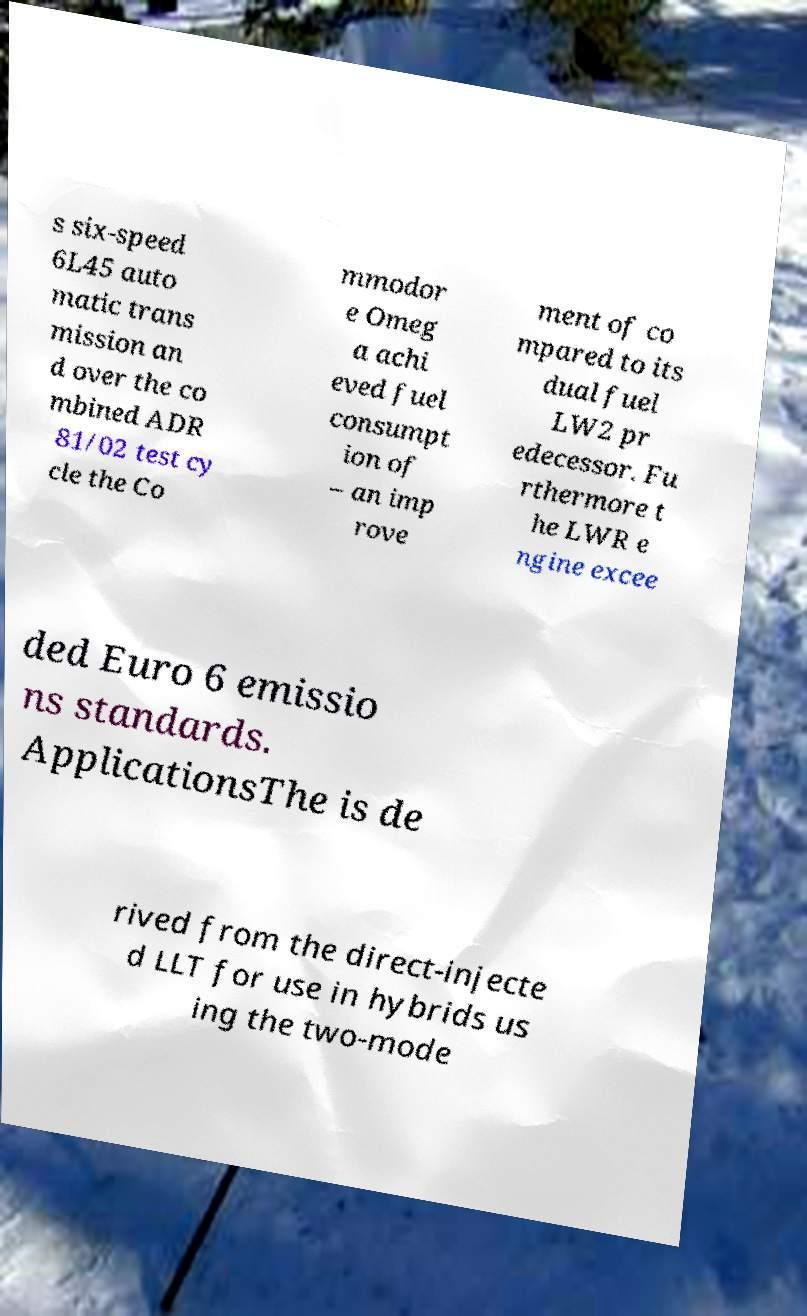Could you extract and type out the text from this image? s six-speed 6L45 auto matic trans mission an d over the co mbined ADR 81/02 test cy cle the Co mmodor e Omeg a achi eved fuel consumpt ion of – an imp rove ment of co mpared to its dual fuel LW2 pr edecessor. Fu rthermore t he LWR e ngine excee ded Euro 6 emissio ns standards. ApplicationsThe is de rived from the direct-injecte d LLT for use in hybrids us ing the two-mode 